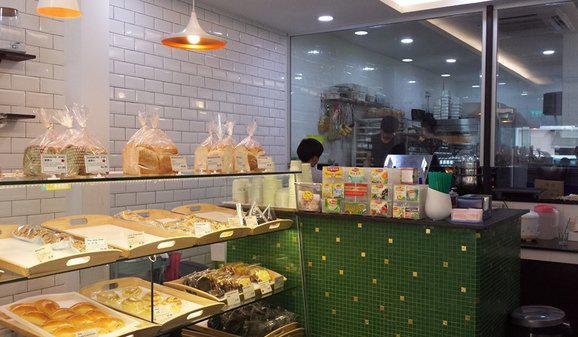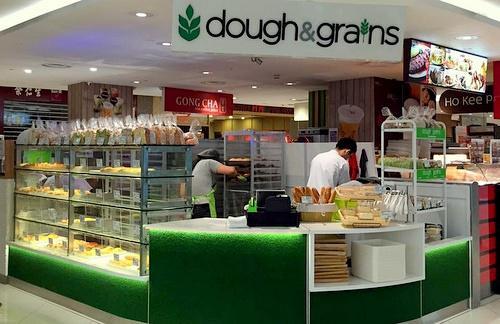The first image is the image on the left, the second image is the image on the right. Assess this claim about the two images: "The left image features tiered shelves behind a glass case filled with side-by-side rectangular trays of baked goods, each with an oval cut-out tray handle facing the glass front.". Correct or not? Answer yes or no. Yes. The first image is the image on the left, the second image is the image on the right. Given the left and right images, does the statement "One of the shops advertises 'dough & grains'." hold true? Answer yes or no. Yes. 